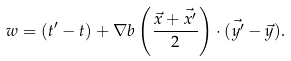Convert formula to latex. <formula><loc_0><loc_0><loc_500><loc_500>w = ( t ^ { \prime } - t ) + \nabla b \left ( \frac { \vec { x } + \vec { x ^ { \prime } } } { 2 } \right ) \cdot ( \vec { y ^ { \prime } } - \vec { y } ) .</formula> 